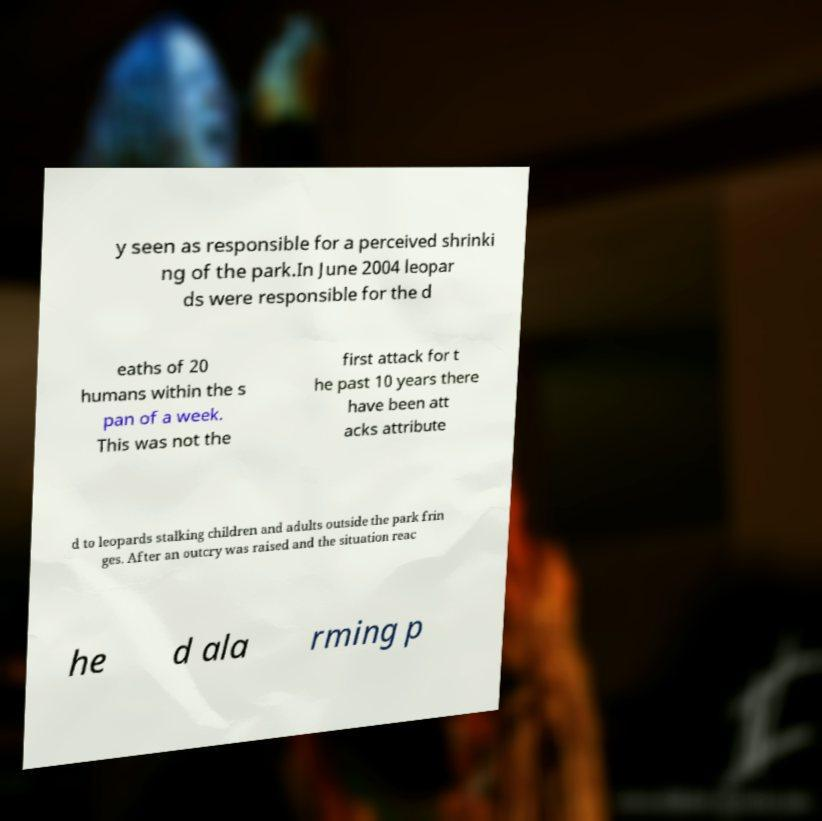Could you assist in decoding the text presented in this image and type it out clearly? y seen as responsible for a perceived shrinki ng of the park.In June 2004 leopar ds were responsible for the d eaths of 20 humans within the s pan of a week. This was not the first attack for t he past 10 years there have been att acks attribute d to leopards stalking children and adults outside the park frin ges. After an outcry was raised and the situation reac he d ala rming p 